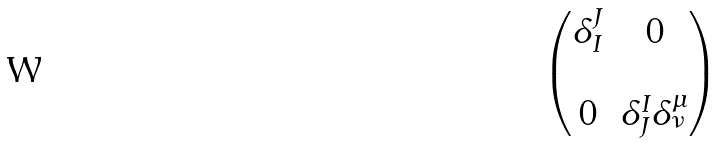Convert formula to latex. <formula><loc_0><loc_0><loc_500><loc_500>\begin{pmatrix} \delta _ { I } ^ { J } & 0 \\ \\ 0 & \delta _ { J } ^ { I } \delta _ { \nu } ^ { \mu } \end{pmatrix}</formula> 